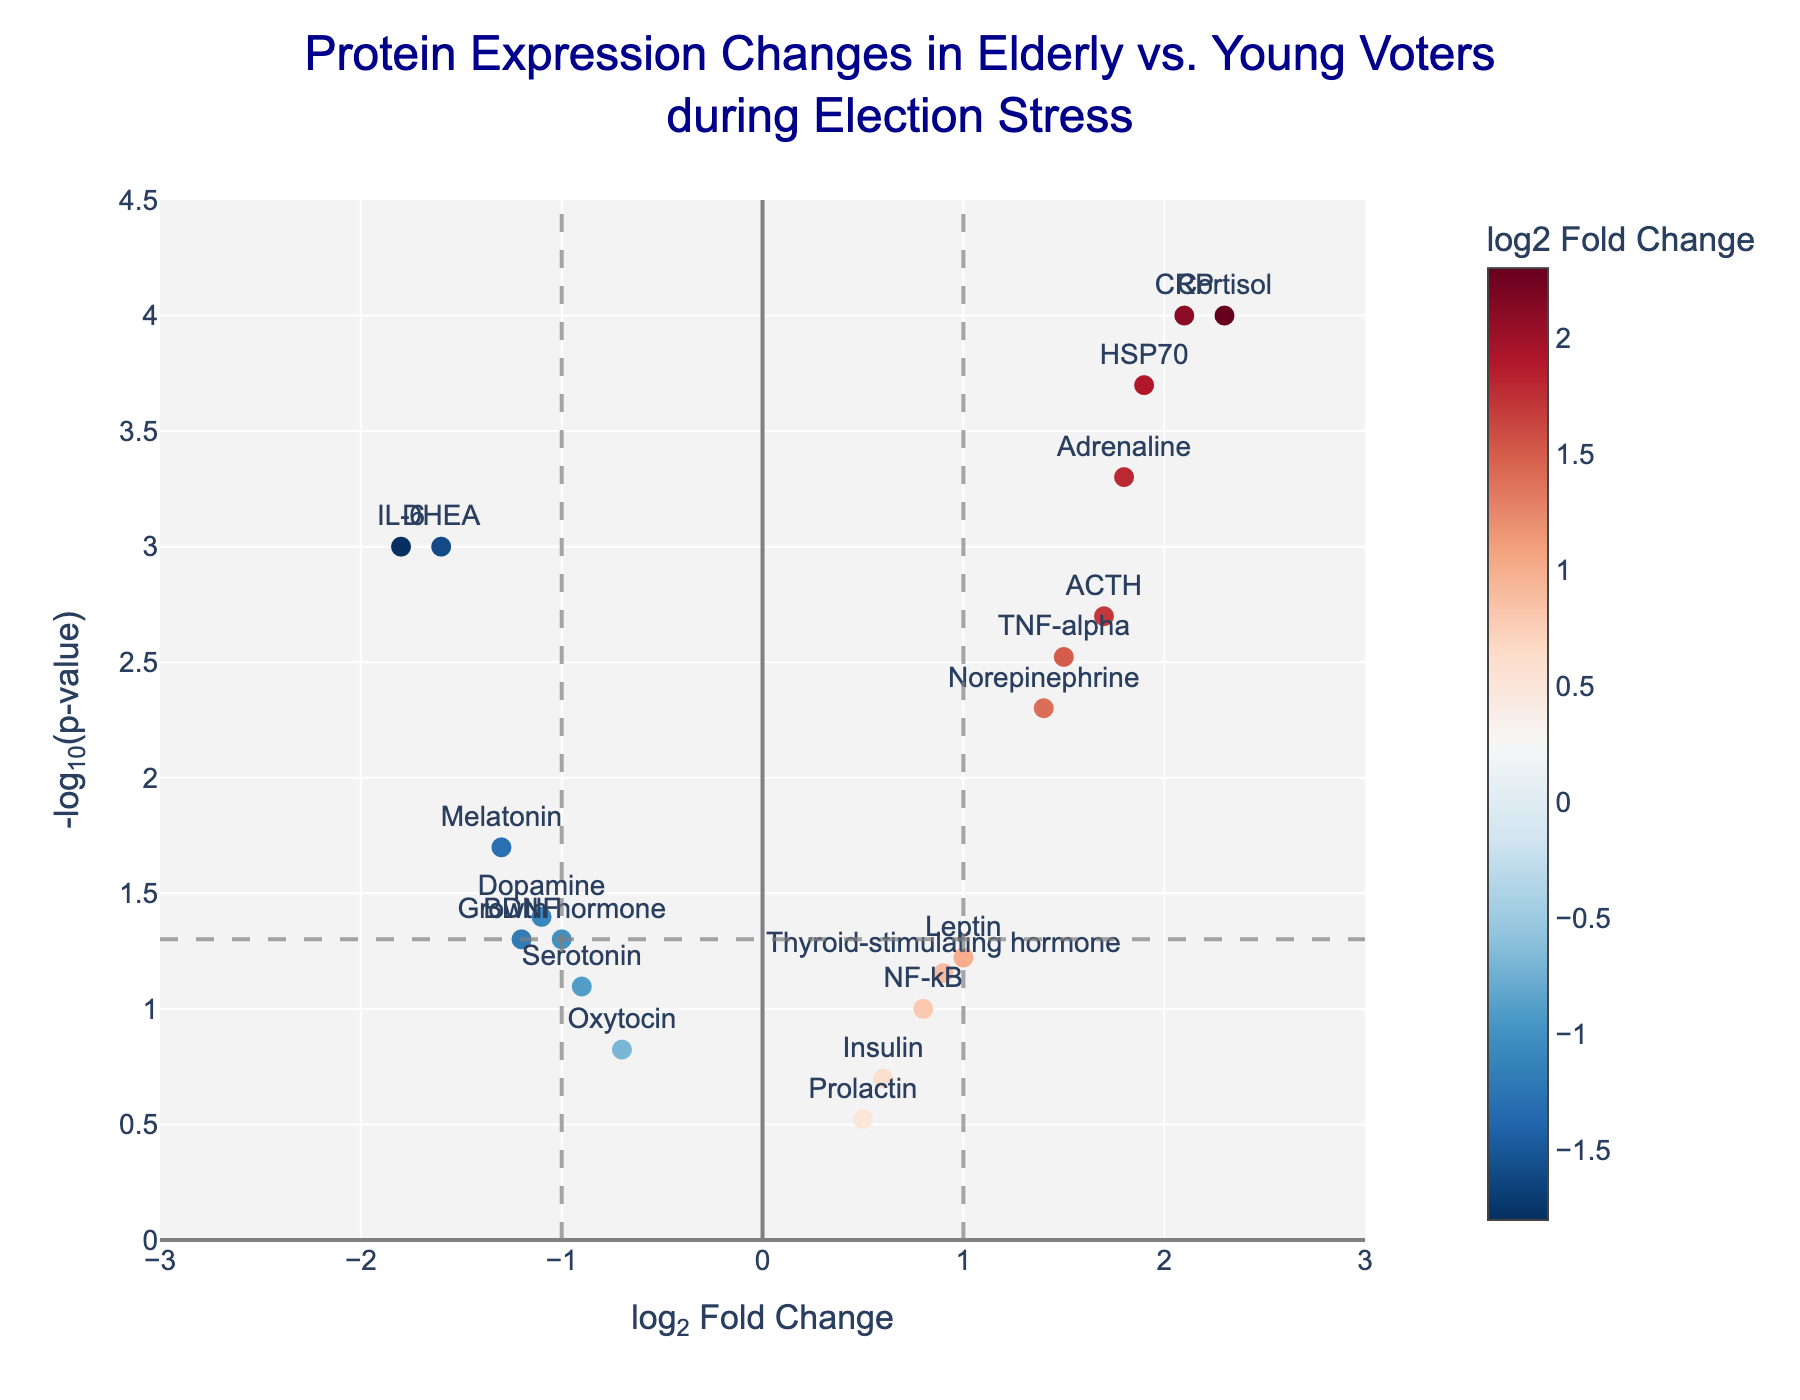How many proteins are displayed on the plot? To find the number of proteins, count the number of markers on the plot. Each marker represents a protein.
Answer: 19 What is the title of the figure? The title is displayed at the top of the figure.
Answer: Protein Expression Changes in Elderly vs. Young Voters during Election Stress Where does the protein IL-6 lie on the plot? For IL-6, find the corresponding marker in the plot. It will be located at the coordinates given by its log2FoldChange (-1.8) on the x-axis and -log10(pValue) (3) on the y-axis.
Answer: (-1.8, 3) Which protein has the highest log2 Fold Change? To find the protein with the highest log2 Fold Change, look for the marker with the highest x-axis value.
Answer: Cortisol Which proteins are significantly upregulated based on the plot? Upregulated proteins have a positive log2 Fold Change and are statistically significant if they have p-values less than 0.05, shown above the dashed horizontal line at y ~ 1.301.
Answer: Cortisol, TNF-alpha, HSP70, ACTH, Norepinephrine, CRP, Adrenaline Which protein has the lowest p-value? Look for the protein marker positioned the highest on the y-axis, as -log10(0.0001) = 4.
Answer: Cortisol What is the log2 Fold Change and p-value for Melatonin? Locate the position of Melatonin on the plot to find its coordinates as annotated. The x-coordinate is its log2 Fold Change, and the y-coordinate can be converted back from -log10(pValue).
Answer: log2 Fold Change: -1.3, p-value: 0.02 Among IL-6 and BDNF, which protein has a more significant change and why? Compare their log2 Fold Changes and p-values. Both proteins are downregulated (negative log2 Fold Change), but the significance comes from the p-value (-log10(pValue)). A higher -log10(pValue) means a lower p-value and more significant change.
Answer: IL-6, because it has a lower p-value (0.001) compared to BDNF (0.05) Are there any proteins with no significant change? If so, name one. Examine markers very close to the dashed horizontal line (-log10(pValue) < 1.301) and see if some of the dots fall below that line. Proteins whose markers fall below this line are not significantly differentially expressed.
Answer: Prolactin What is the significance threshold line on the y-axis? The horizontal dashed line corresponds to the p-value threshold of 0.05, which translates to -log10(0.05) ≈ 1.301.
Answer: -log10(0.05) 